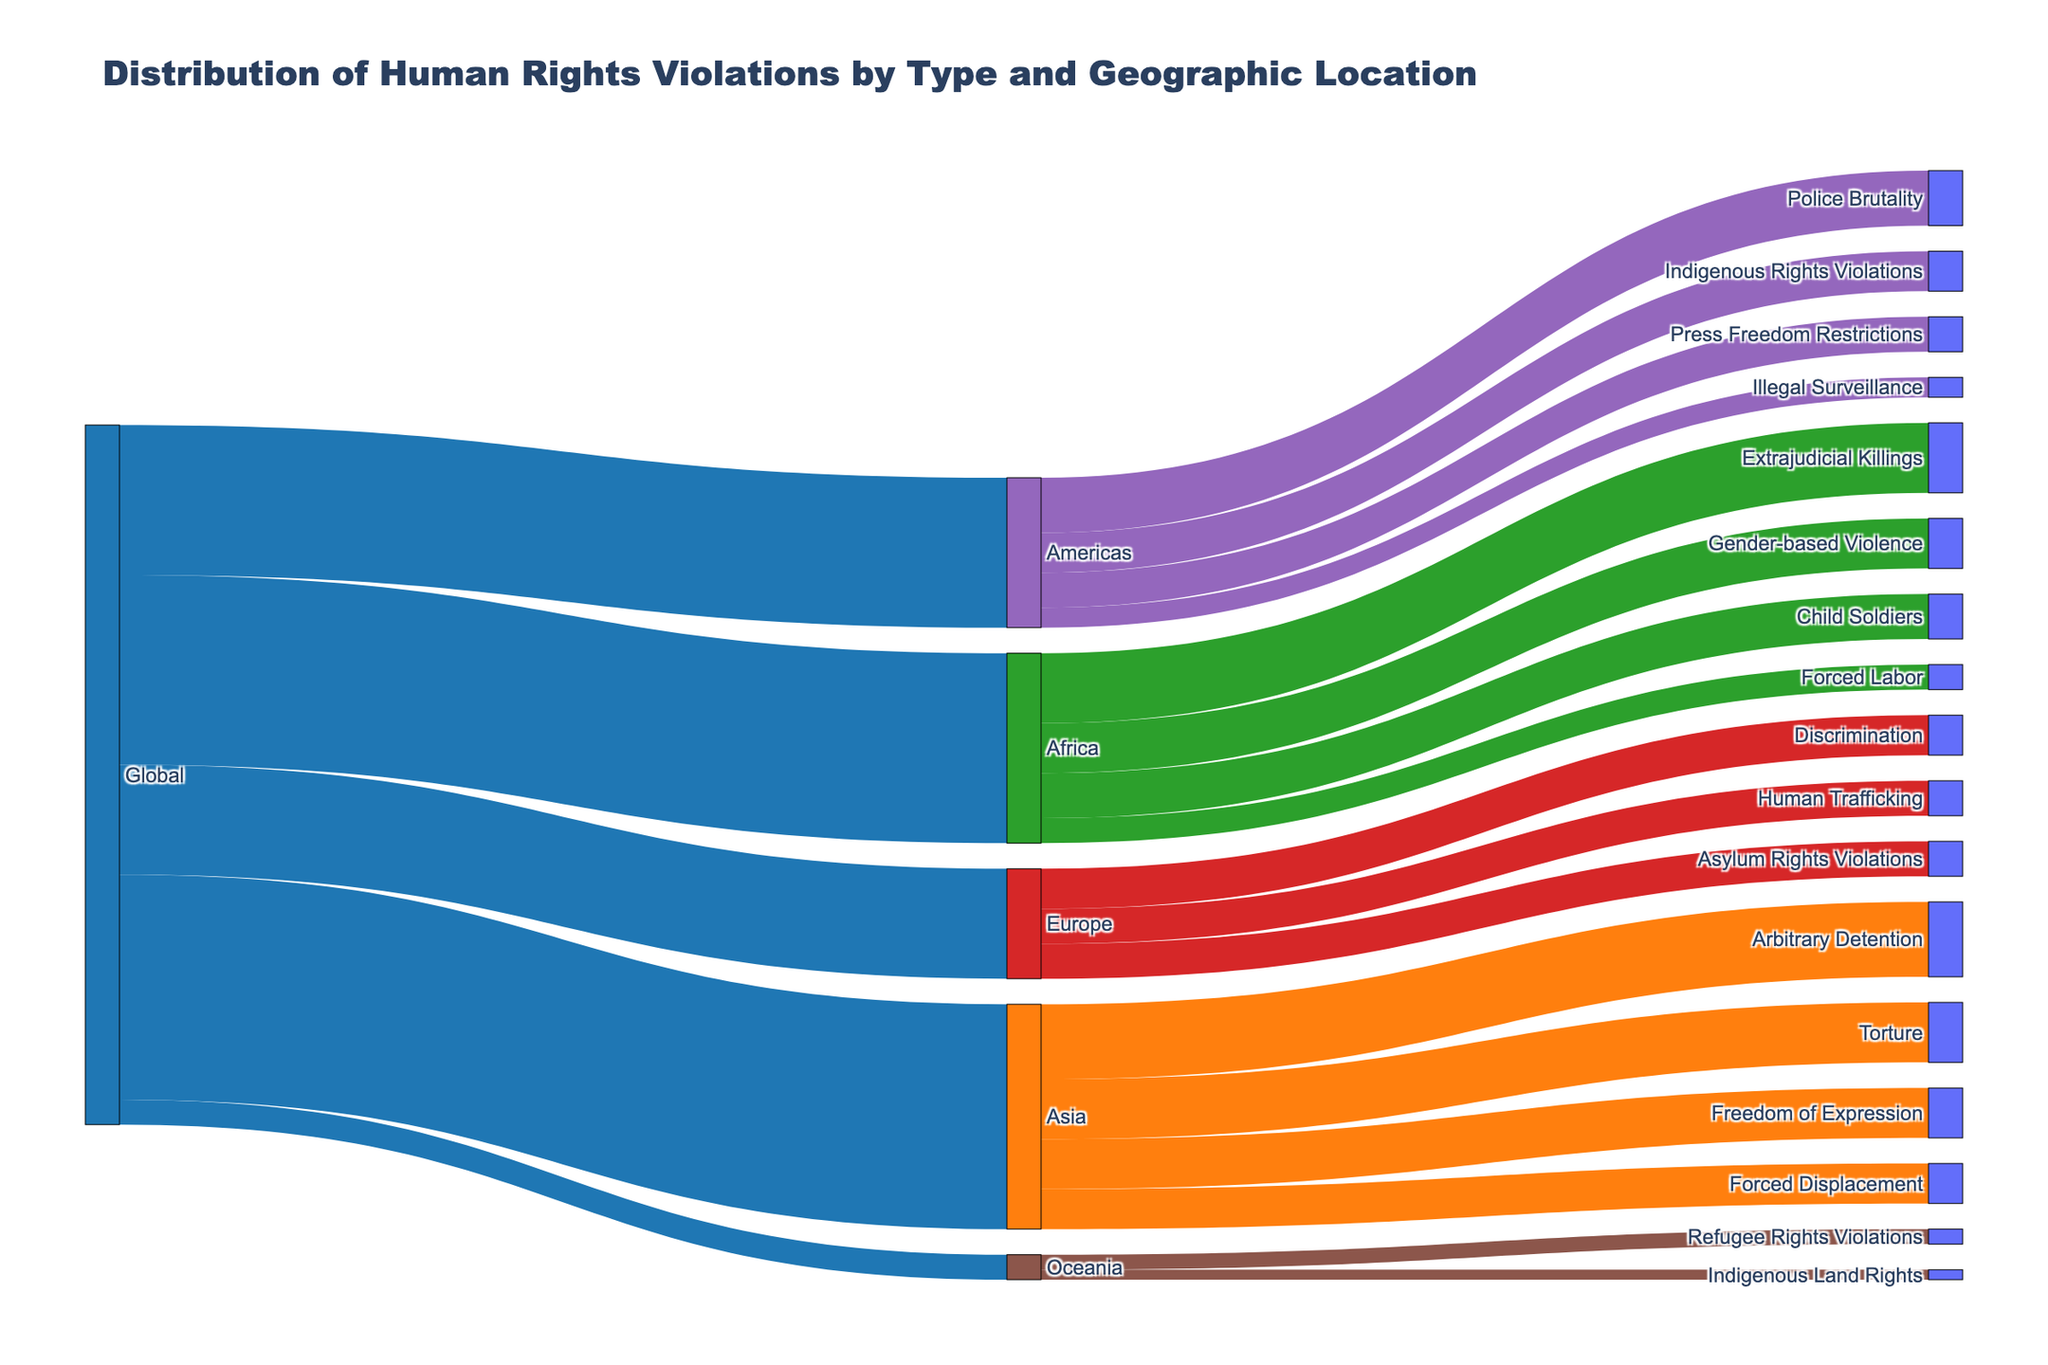What's the title of the figure? The title is usually displayed at the top of the figure. Here it reads "Distribution of Human Rights Violations by Type and Geographic Location".
Answer: Distribution of Human Rights Violations by Type and Geographic Location Which geographic location has the highest number of human rights violations reported? Look for the geographical location with the highest value connected from "Global". Asia has the highest number with 450 reported violations.
Answer: Asia What is the combined total of reported human rights violations in Africa and Oceania? Sum the human rights violations reported in Africa (380) and Oceania (50). 380 + 50 = 430.
Answer: 430 What type of human rights violation is most prevalent in the Americas? Look for the largest value among the types of violations connected to "Americas". Police Brutality has the highest number with 110.
Answer: Police Brutality How many more reported violations are there in Asia compared to Europe? Subtract the number of violations in Europe (220) from those in Asia (450). 450 - 220 = 230.
Answer: 230 Which region reports the highest instances of Extrajudicial Killings? Extrajudicial Killings is reported in Africa with a total of 140, as it is the only region connected to this type of violation.
Answer: Africa Compare the number of Arbitrary Detention cases in Asia to Refugee Rights Violations in Oceania. Which is higher and by how much? In Asia, there are 150 Arbitrary Detention cases. In Oceania, there are 30 Refugee Rights Violations. Subtract 30 from 150, resulting in 120 more cases in Asia.
Answer: Asia by 120 How many types of human rights violations are reported in Europe? Count the number of different violations connected to Europe. There are three: Discrimination, Human Trafficking, and Asylum Rights Violations.
Answer: 3 What is the total number of reports involving Arbitrary Detention, Torture, and Freedom of Expression in Asia? Sum the values of these three types in Asia: Arbitrary Detention (150), Torture (120), Freedom of Expression (100). 150 + 120 + 100 = 370.
Answer: 370 Among the reported human rights violations in the Americas, which type accounts for the smallest number? Look for the type with the smallest value connected to "Americas". Illegal Surveillance has the smallest number with 40.
Answer: Illegal Surveillance 